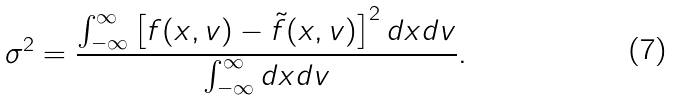<formula> <loc_0><loc_0><loc_500><loc_500>\sigma ^ { 2 } = \frac { \int _ { - \infty } ^ { \infty } \left [ f ( x , v ) - \tilde { f } ( x , v ) \right ] ^ { 2 } d x d v } { \int _ { - \infty } ^ { \infty } d x d v } .</formula> 